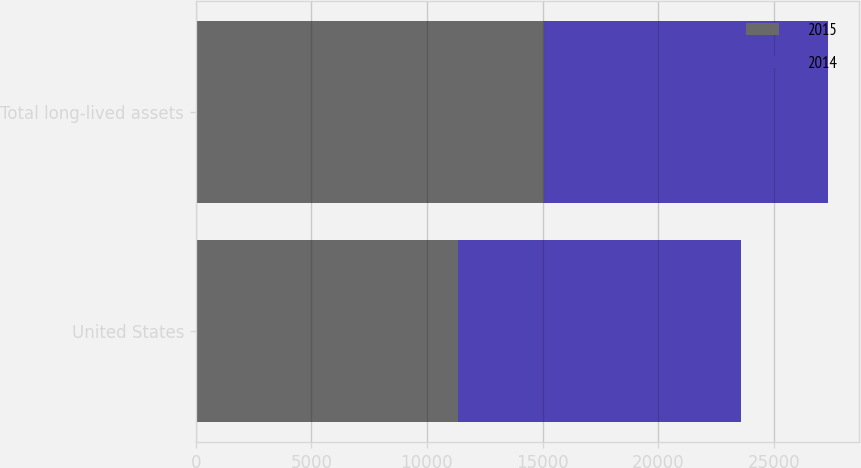<chart> <loc_0><loc_0><loc_500><loc_500><stacked_bar_chart><ecel><fcel>United States<fcel>Total long-lived assets<nl><fcel>2015<fcel>11327<fcel>15068<nl><fcel>2014<fcel>12257<fcel>12257<nl></chart> 